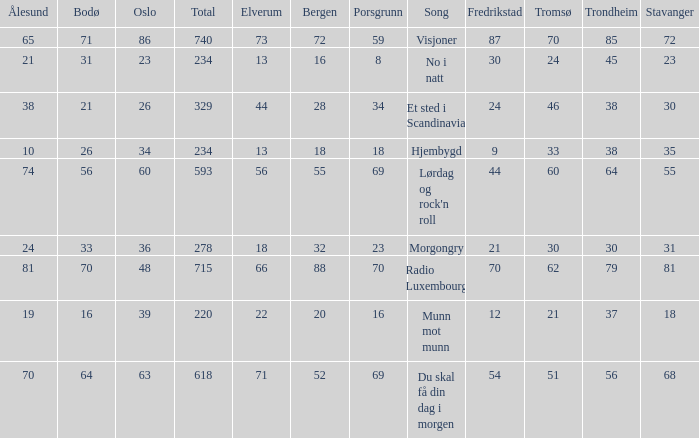How many elverum are tehre for et sted i scandinavia? 1.0. 